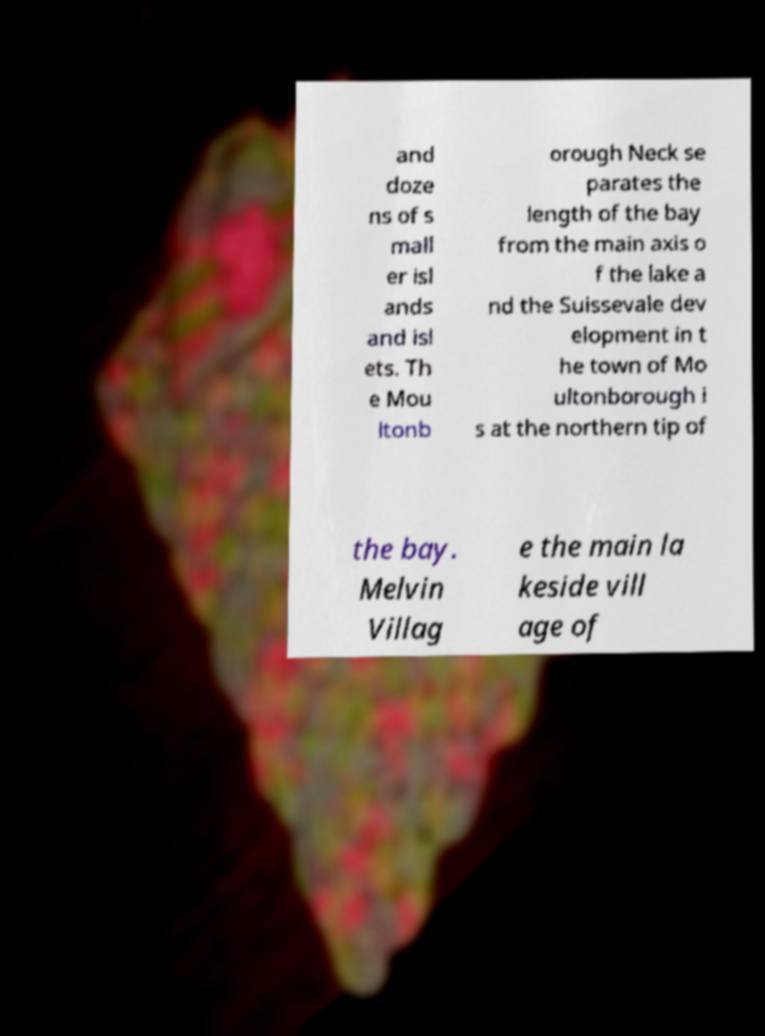What messages or text are displayed in this image? I need them in a readable, typed format. and doze ns of s mall er isl ands and isl ets. Th e Mou ltonb orough Neck se parates the length of the bay from the main axis o f the lake a nd the Suissevale dev elopment in t he town of Mo ultonborough i s at the northern tip of the bay. Melvin Villag e the main la keside vill age of 